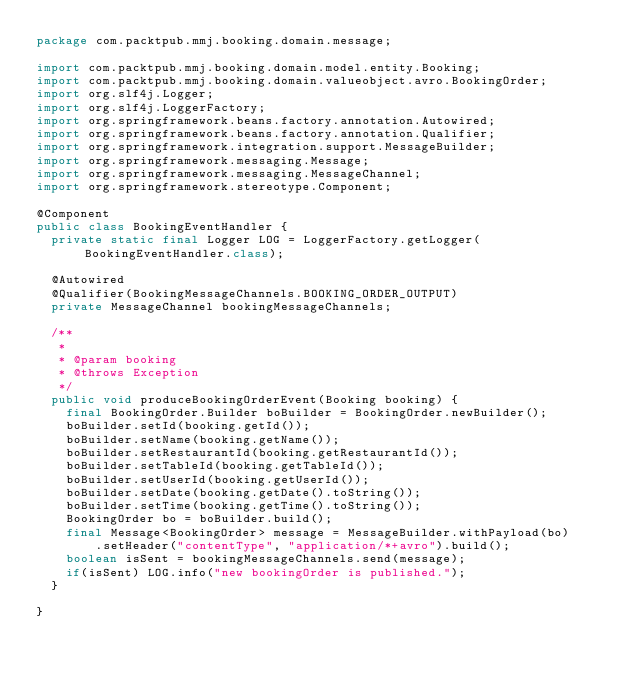Convert code to text. <code><loc_0><loc_0><loc_500><loc_500><_Java_>package com.packtpub.mmj.booking.domain.message;

import com.packtpub.mmj.booking.domain.model.entity.Booking;
import com.packtpub.mmj.booking.domain.valueobject.avro.BookingOrder;
import org.slf4j.Logger;
import org.slf4j.LoggerFactory;
import org.springframework.beans.factory.annotation.Autowired;
import org.springframework.beans.factory.annotation.Qualifier;
import org.springframework.integration.support.MessageBuilder;
import org.springframework.messaging.Message;
import org.springframework.messaging.MessageChannel;
import org.springframework.stereotype.Component;

@Component
public class BookingEventHandler {
  private static final Logger LOG = LoggerFactory.getLogger(BookingEventHandler.class);

  @Autowired
  @Qualifier(BookingMessageChannels.BOOKING_ORDER_OUTPUT)
  private MessageChannel bookingMessageChannels;

  /**
   *
   * @param booking
   * @throws Exception
   */
  public void produceBookingOrderEvent(Booking booking) {
    final BookingOrder.Builder boBuilder = BookingOrder.newBuilder();
    boBuilder.setId(booking.getId());
    boBuilder.setName(booking.getName());
    boBuilder.setRestaurantId(booking.getRestaurantId());
    boBuilder.setTableId(booking.getTableId());
    boBuilder.setUserId(booking.getUserId());
    boBuilder.setDate(booking.getDate().toString());
    boBuilder.setTime(booking.getTime().toString());
    BookingOrder bo = boBuilder.build();
    final Message<BookingOrder> message = MessageBuilder.withPayload(bo)
        .setHeader("contentType", "application/*+avro").build();
    boolean isSent = bookingMessageChannels.send(message);
    if(isSent) LOG.info("new bookingOrder is published.");
  }

}
</code> 